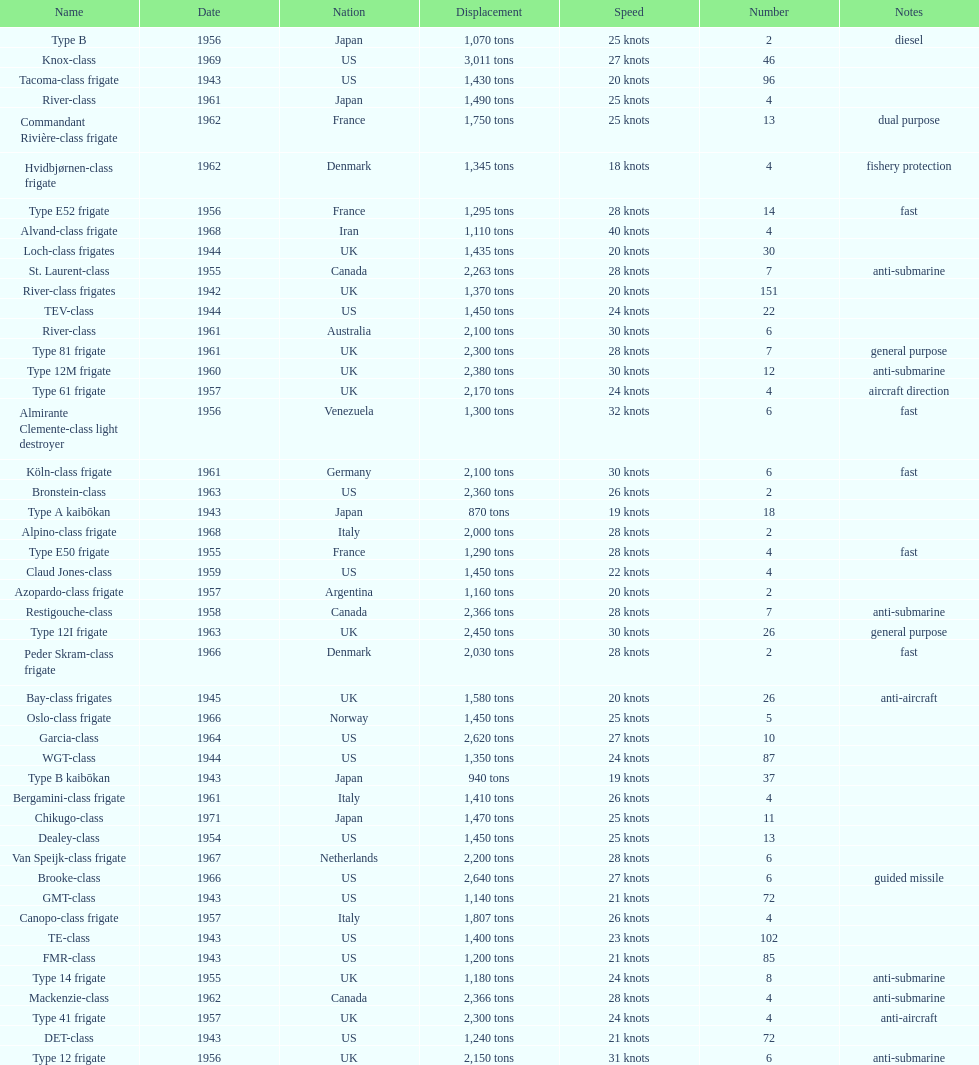In 1968 italy used alpino-class frigate. what was its top speed? 28 knots. 